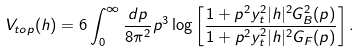Convert formula to latex. <formula><loc_0><loc_0><loc_500><loc_500>V _ { t o p } ( h ) = 6 \int _ { 0 } ^ { \infty } \frac { d p } { 8 \pi ^ { 2 } } p ^ { 3 } \log \left [ \frac { 1 + p ^ { 2 } y _ { t } ^ { 2 } | h | ^ { 2 } G _ { B } ^ { 2 } ( p ) } { 1 + p ^ { 2 } y _ { t } ^ { 2 } | h | ^ { 2 } G _ { F } ( p ) } \right ] .</formula> 